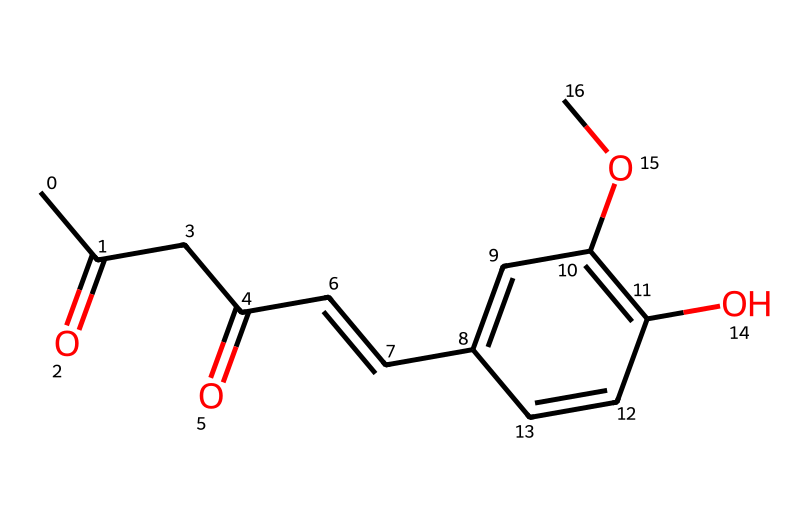What is the molecular formula of curcumin? To find the molecular formula, count the number of each type of atom in the SMILES representation. There are 21 carbons, 20 hydrogens, and 6 oxygens. Thus, the formula is C21H20O6.
Answer: C21H20O6 How many rings are in the molecular structure? Looking at the structure, there is one cyclic part designated by the bond structure which indicates that it is aromatic (benzene-like). Therefore, there is one ring in the structure.
Answer: 1 What type of functional groups are present in curcumin? By analyzing the molecular structure, we see carbonyl groups (C=O) and hydroxy groups (OH) as the significant functional groups present in curcumin.
Answer: carbonyl and hydroxy How many double bonds are present in the structure? By examining the structure, there are several instances where double bonds appear. In total, counting each double bond gives us a total of 6 double bonds in the molecular structure.
Answer: 6 What property does curcumin's aromatic ring contribute to its antioxidant activity? The presence of an aromatic ring in curcumin allows for delocalization of electrons which can stabilize free radicals, enhancing its antioxidant properties.
Answer: electron delocalization Which element primarily contributes to curcumin's color? The conjugated system within the structure, particularly the conjugated double bonds in the aromatic rings, is responsible for the vibrant yellow color of curcumin.
Answer: conjugated system 